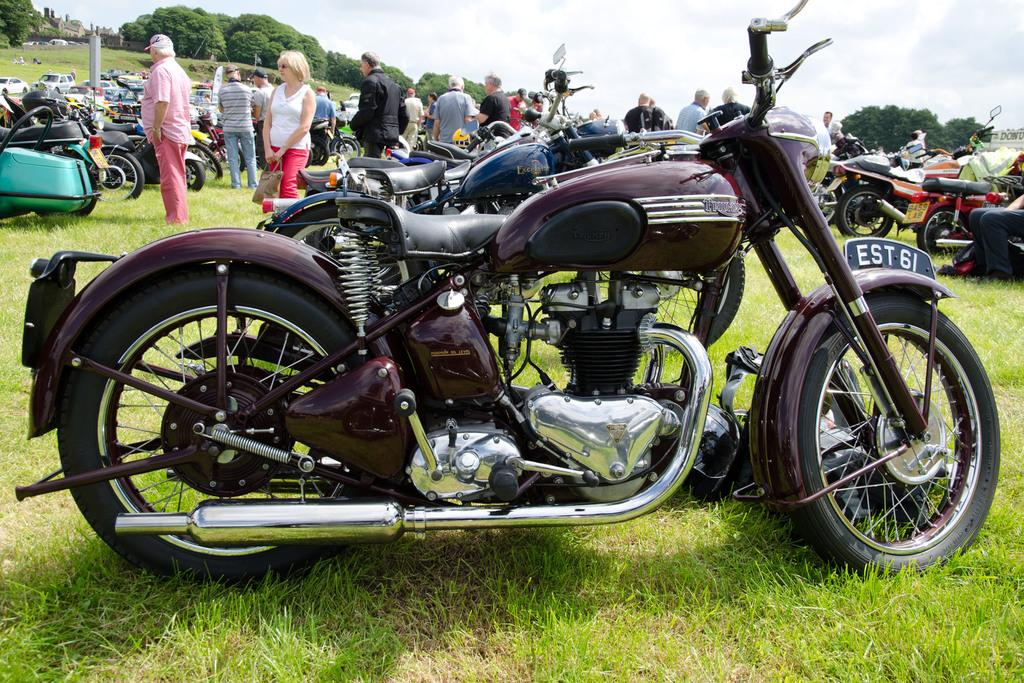What types of vehicles can be seen in the image? There are vehicles in the image, but the specific types are not mentioned. Where are the motorbikes located in the image? The motorbikes are parked on the grass in the image. Can you describe the group of people at the top of the image? There is a group of people at the top of the image, but their specific actions or characteristics are not mentioned. What natural elements are visible in the image? Trees and the sky are visible in the image. What is the woman holding in the image? The woman is holding a bag in the image. What color is the nose of the person in the image? There is no mention of a person's nose in the image, so it cannot be determined. What type of system is being used by the motorbikes in the image? There is no mention of a system being used by the motorbikes in the image. Can you tell me how many apples are on the trees in the image? There is no mention of trees having apples in the image. 